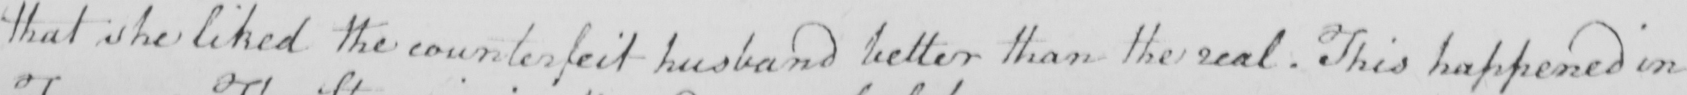What text is written in this handwritten line? that she liked the counterfeit husband better than the real . This happened in 